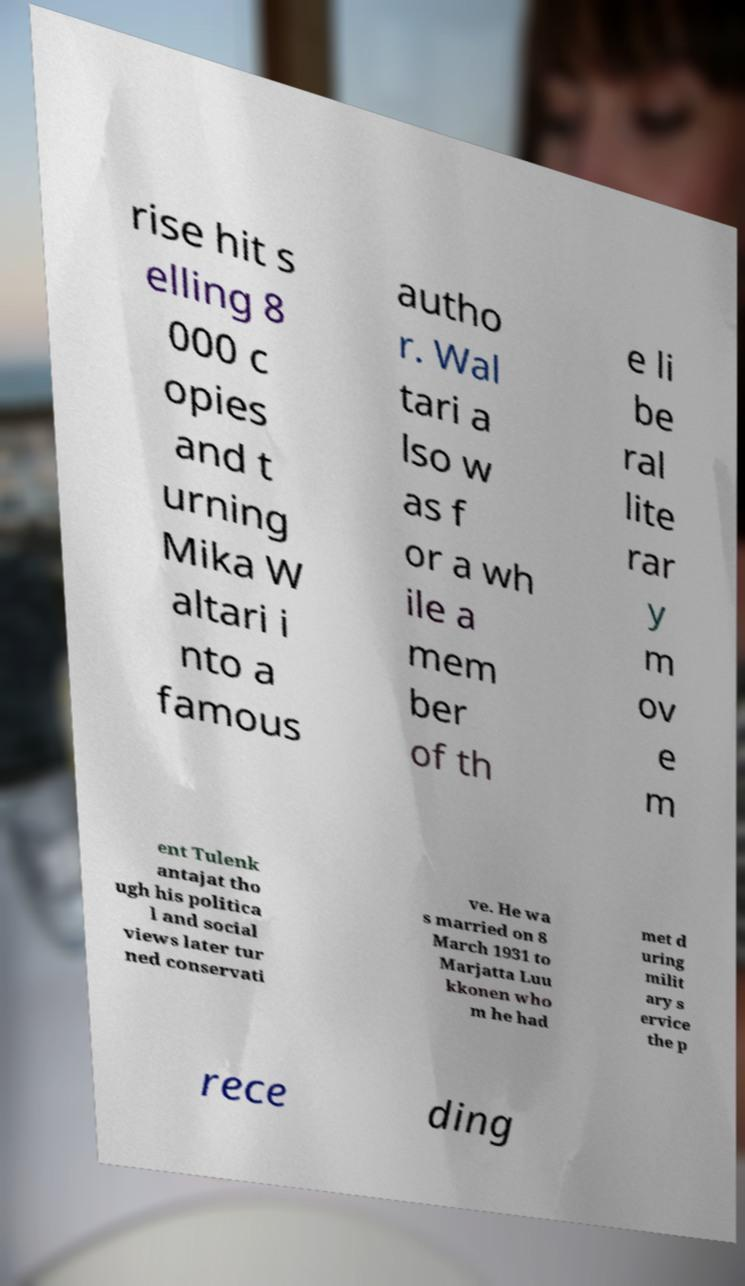Can you read and provide the text displayed in the image?This photo seems to have some interesting text. Can you extract and type it out for me? rise hit s elling 8 000 c opies and t urning Mika W altari i nto a famous autho r. Wal tari a lso w as f or a wh ile a mem ber of th e li be ral lite rar y m ov e m ent Tulenk antajat tho ugh his politica l and social views later tur ned conservati ve. He wa s married on 8 March 1931 to Marjatta Luu kkonen who m he had met d uring milit ary s ervice the p rece ding 